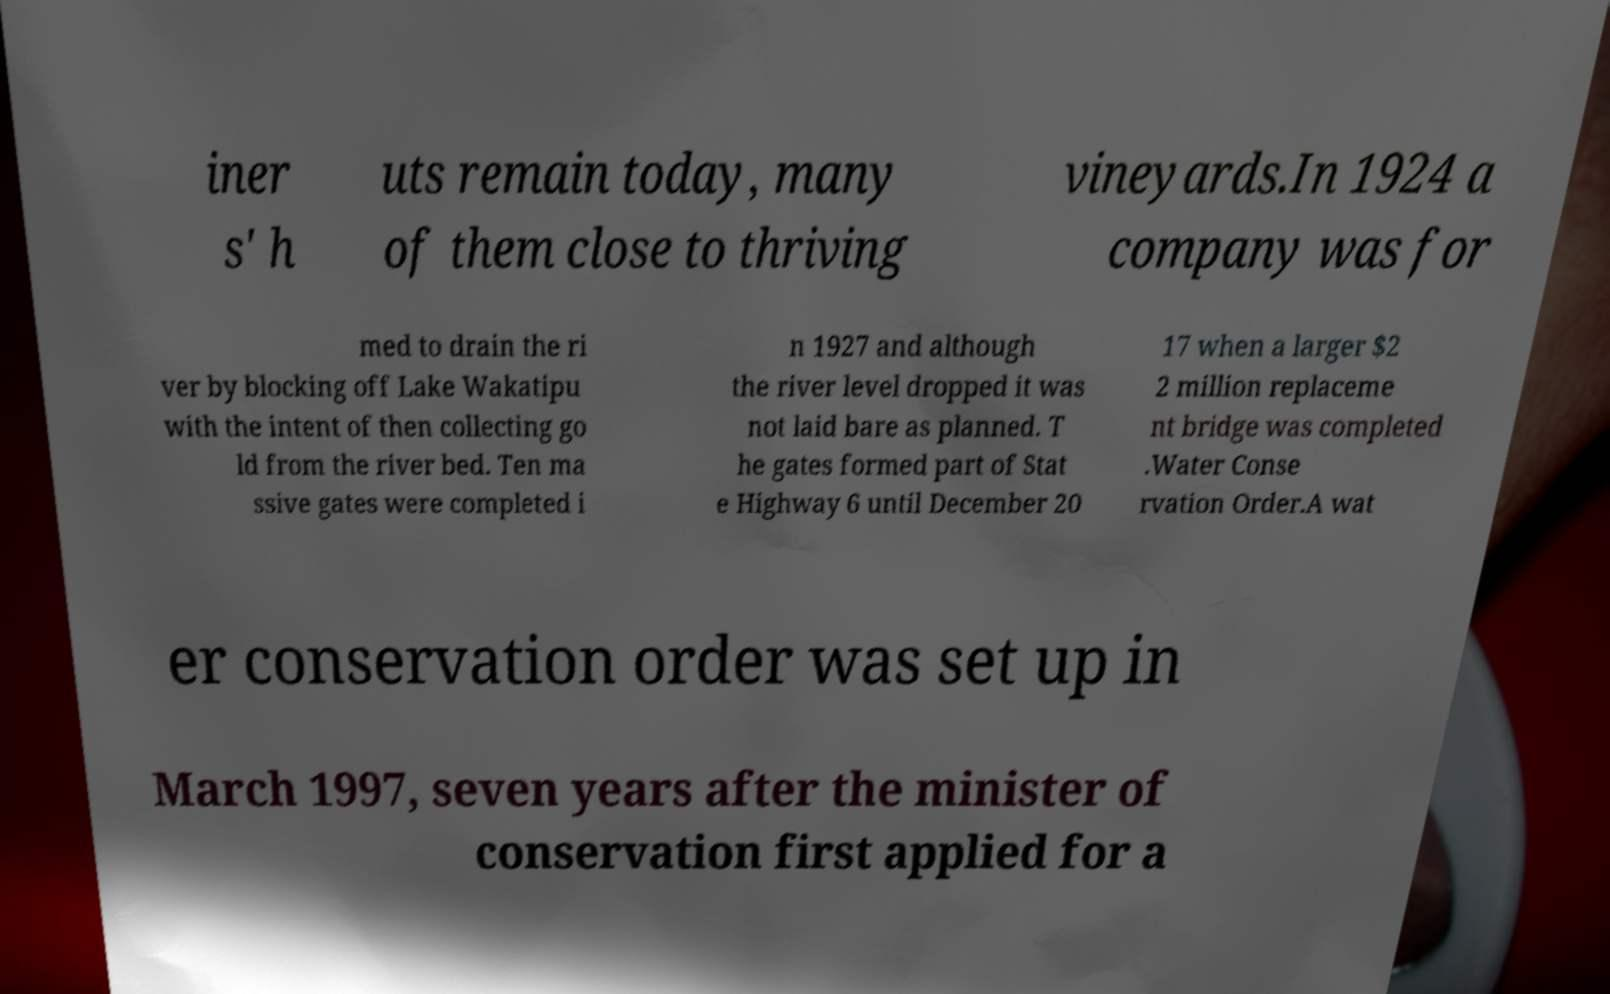Can you read and provide the text displayed in the image?This photo seems to have some interesting text. Can you extract and type it out for me? iner s' h uts remain today, many of them close to thriving vineyards.In 1924 a company was for med to drain the ri ver by blocking off Lake Wakatipu with the intent of then collecting go ld from the river bed. Ten ma ssive gates were completed i n 1927 and although the river level dropped it was not laid bare as planned. T he gates formed part of Stat e Highway 6 until December 20 17 when a larger $2 2 million replaceme nt bridge was completed .Water Conse rvation Order.A wat er conservation order was set up in March 1997, seven years after the minister of conservation first applied for a 